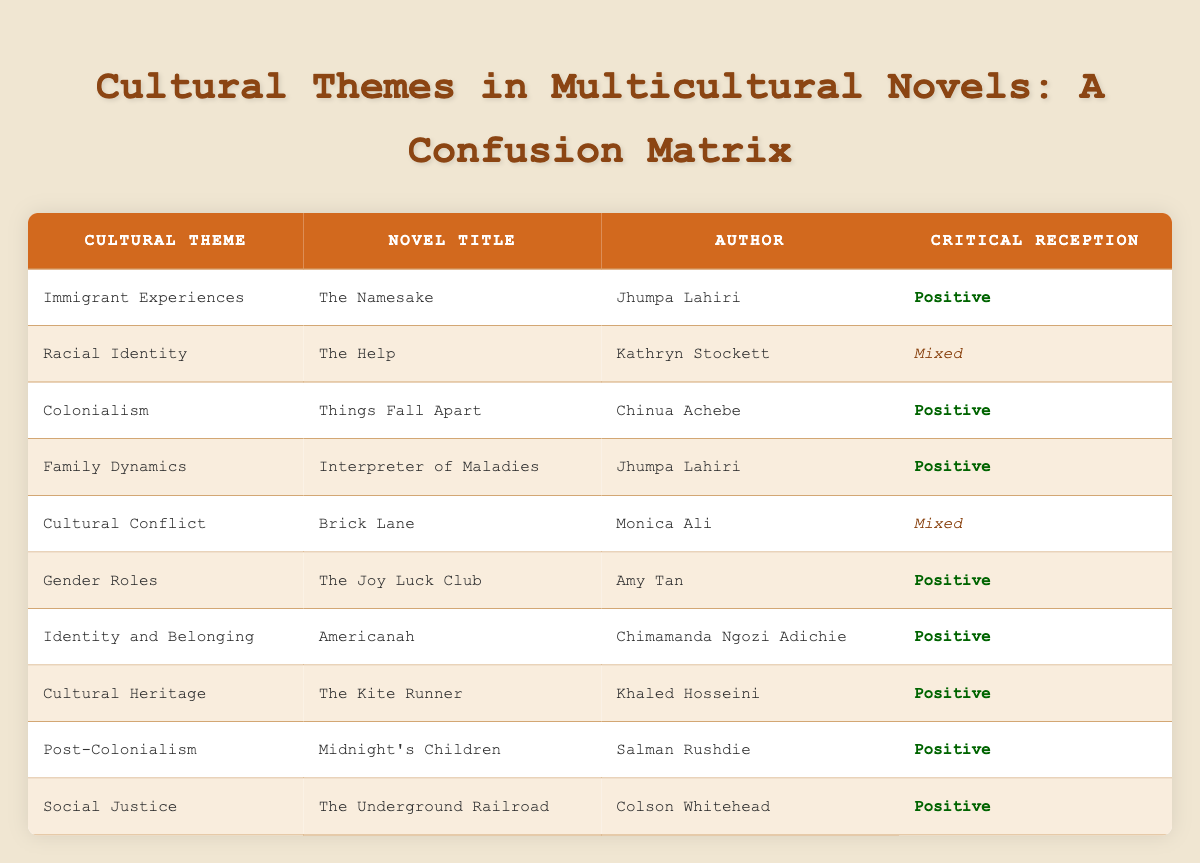What cultural theme does "The Kite Runner" explore? According to the table, "The Kite Runner" explores the cultural theme of "Cultural Heritage."
Answer: Cultural Heritage Which novel received a mixed critical reception? The table lists "The Help" and "Brick Lane" as novels with mixed critical receptions.
Answer: The Help, Brick Lane How many novels focus on themes of "Identity and Belonging" or "Gender Roles"? There is one novel for "Gender Roles" (The Joy Luck Club) and one for "Identity and Belonging" (Americanah), making a total of two novels.
Answer: 2 Is "Interpreter of Maladies" positively received? The table indicates that the critical reception of "Interpreter of Maladies" is listed as positive.
Answer: Yes Which author has written multiple novels that are positively received? Jhumpa Lahiri is the author who has written two positively received novels: "The Namesake" and "Interpreter of Maladies."
Answer: Jhumpa Lahiri What is the total number of novels listed in the table that explore themes of "Post-Colonialism"? The table shows "Midnight's Children" as the only novel that explores the theme of "Post-Colonialism."
Answer: 1 Which novel has a critical reception of 'Positive' that explores "Family Dynamics"? The novel "Interpreter of Maladies" explores "Family Dynamics" and has a positive critical reception.
Answer: Interpreter of Maladies What are the cultural themes associated with novels that received a positive critical reception? The themes associated with positively received novels are "Immigrant Experiences," "Colonialism," "Family Dynamics," "Gender Roles," "Identity and Belonging," "Cultural Heritage," "Post-Colonialism," and "Social Justice."
Answer: 8 themes Which cultural themes are associated with mixed critical reception novels? The cultural themes associated with mixed critical reception novels are "Racial Identity" and "Cultural Conflict."
Answer: Racial Identity, Cultural Conflict 